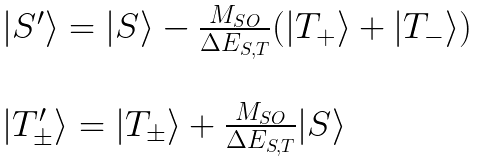<formula> <loc_0><loc_0><loc_500><loc_500>\begin{array} { l l l } | S ^ { \prime } \rangle = | S \rangle - \frac { M _ { S O } } { \Delta E _ { S , T } } ( | T _ { + } \rangle + | T _ { - } \rangle ) \\ \\ | T ^ { \prime } _ { \pm } \rangle = | T _ { \pm } \rangle + \frac { M _ { S O } } { \Delta E _ { S , T } } | S \rangle \end{array}</formula> 